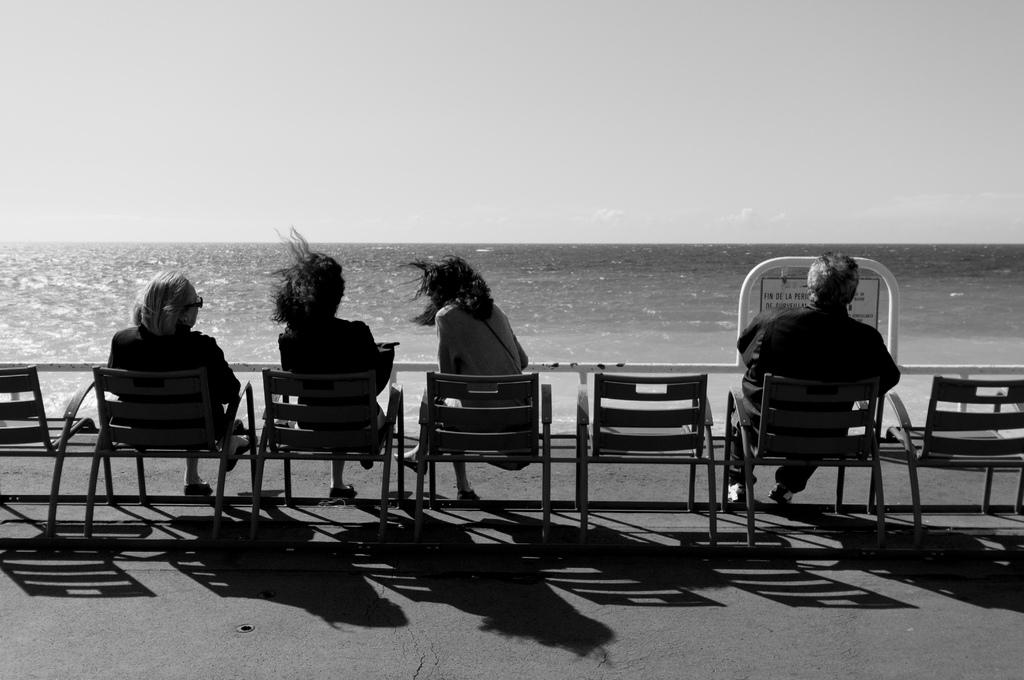How many people are in the image? There are four people in the image. Can you describe the gender of the people in the image? One of the people is a man, and three of the people are women. What are the people doing in the image? The people are sitting in chairs and looking at water. What is visible at the top of the image? The sky is visible at the top of the image. What type of detail can be seen on the mice in the image? There are no mice present in the image, so it is not possible to determine what type of detail might be seen on them. 